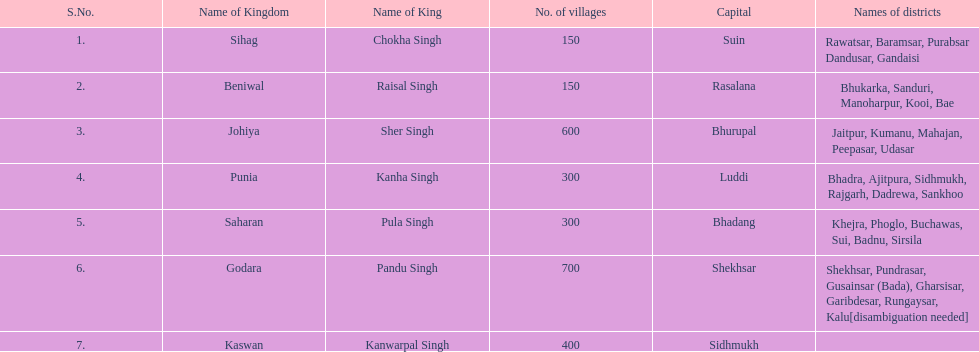Does punia have more or less villages than godara? Less. 